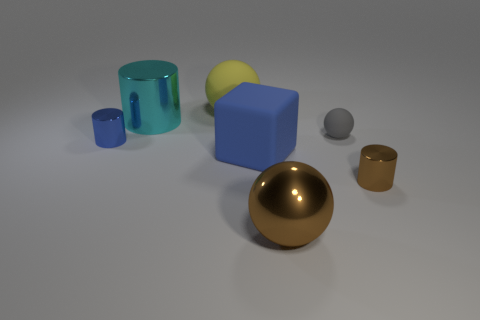Are there any other things that are the same shape as the large blue object?
Provide a short and direct response. No. Are there any other things that have the same size as the gray thing?
Offer a terse response. Yes. Are there an equal number of shiny cylinders on the left side of the small brown cylinder and cyan cylinders to the left of the small blue metal cylinder?
Make the answer very short. No. There is a cylinder on the right side of the cyan cylinder; does it have the same size as the matte object that is in front of the gray ball?
Your answer should be very brief. No. There is a tiny thing that is to the right of the blue matte block and behind the small brown cylinder; what is its material?
Make the answer very short. Rubber. Are there fewer brown metal things than big cyan metallic balls?
Your response must be concise. No. There is a rubber ball that is on the right side of the large sphere behind the small blue metallic cylinder; what size is it?
Your response must be concise. Small. What shape is the metallic thing in front of the brown metal object behind the brown shiny thing that is in front of the small brown thing?
Make the answer very short. Sphere. What is the color of the ball that is the same material as the blue cylinder?
Your answer should be compact. Brown. There is a large matte thing that is in front of the metallic cylinder on the left side of the cyan metal object to the left of the matte block; what is its color?
Ensure brevity in your answer.  Blue. 